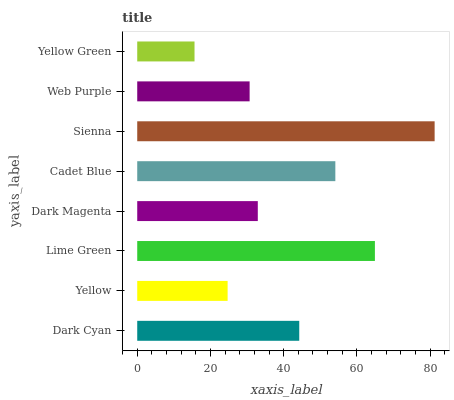Is Yellow Green the minimum?
Answer yes or no. Yes. Is Sienna the maximum?
Answer yes or no. Yes. Is Yellow the minimum?
Answer yes or no. No. Is Yellow the maximum?
Answer yes or no. No. Is Dark Cyan greater than Yellow?
Answer yes or no. Yes. Is Yellow less than Dark Cyan?
Answer yes or no. Yes. Is Yellow greater than Dark Cyan?
Answer yes or no. No. Is Dark Cyan less than Yellow?
Answer yes or no. No. Is Dark Cyan the high median?
Answer yes or no. Yes. Is Dark Magenta the low median?
Answer yes or no. Yes. Is Sienna the high median?
Answer yes or no. No. Is Yellow the low median?
Answer yes or no. No. 